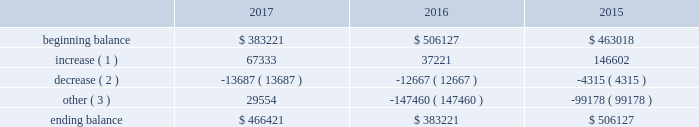The principal components of eog's rollforward of valuation allowances for deferred income tax assets were as follows ( in thousands ) : .
( 1 ) increase in valuation allowance related to the generation of tax nols and other deferred tax assets .
( 2 ) decrease in valuation allowance associated with adjustments to certain deferred tax assets and their related allowance .
( 3 ) represents dispositions/revisions/foreign exchange rate variances and the effect of statutory income tax rate changes .
As of december 31 , 2017 , eog had state income tax nols being carried forward of approximately $ 1.7 billion , which , if unused , expire between 2018 and 2036 .
During 2017 , eog's united kingdom subsidiary incurred a tax nol of approximately $ 72 million which , along with prior years' nols of $ 857 million , will be carried forward indefinitely .
Eog also has united states federal and canadian nols of $ 335 million and $ 158 million , respectively , with varying carryforward periods .
Eog's remaining amt credits total $ 798 million , resulting from amt paid with respect to prior years and an increase of $ 41 million in 2017 .
As described above , these nols and credits , as well as other less significant future income tax benefits , have been evaluated for the likelihood of utilization , and valuation allowances have been established for the portion of these deferred income tax assets that t do not meet the "more likely than not" threshold .
As further described above , significant changes were made by the tcja to the corporate amt that are favorable to eog , including the refunding of amt credit carryovers .
Due to these legislative changes , eog intends to settle certain uncertain tax positions related to amt credits for taxable years 2011 through 2015 , resulting in a decrease of uncertain tax positions of $ 40 million .
The amount of unrecognized tax benefits at december 31 , 2017 , was $ 39 million , resulting from the tax treatment of its research and experimental expenditures related to certain innovations in its horizontal drilling and completion projects , which ish not expected to have an earnings impact .
Eog records interest and penalties related to unrecognized tax benefits to its income tax provision .
Eog does not anticipate that the amount of the unrecognized tax benefits will increase during the next twelve months .
Eog and its subsidiaries file income tax returns and are subject to tax audits in the united states and various state , local and foreign jurisdictions .
Eog's earliest open tax years in its principal jurisdictions are as follows : united states federal ( 2011 ) , canada ( 2014 ) , united kingdom ( 2016 ) , trinidad ( 2011 ) and china ( 2008 ) .
Eog's foreign subsidiaries' undistributed earnings are no longer considered to be permanently reinvested outside the u.s .
And , accordingly , eog has cumulatively recorded $ 20 million of foreign and state deferred income taxes as of december 31 , 2017 .
Employee benefit plans stock-based compensation during 2017 , eog maintained various stock-based compensation plans as discussed below .
Eog recognizes compensation expense on grants of stock options , sars , restricted stock and restricted stock units , performance units and grants made under the eog resources , inc .
Employee stock purchase plan ( espp ) .
Stock-based compensation expense is calculated based upon the grant date estimated fair value of the awards , net of forfeitures , based upon eog's historical employee turnover rate .
Compensation expense is amortized over the shorter of the vesting period or the period from date of grant until the date the employee becomes eligible to retire without company approval. .
Considering the eog's roll forward of valuation allowances for deferred income tax assets during 2015-2017 , what was the lowest value registered in the beginning balance? 
Rationale: it is the minimum value of this period .
Computations: table_min(beginning balance, none)
Answer: 383221.0. 